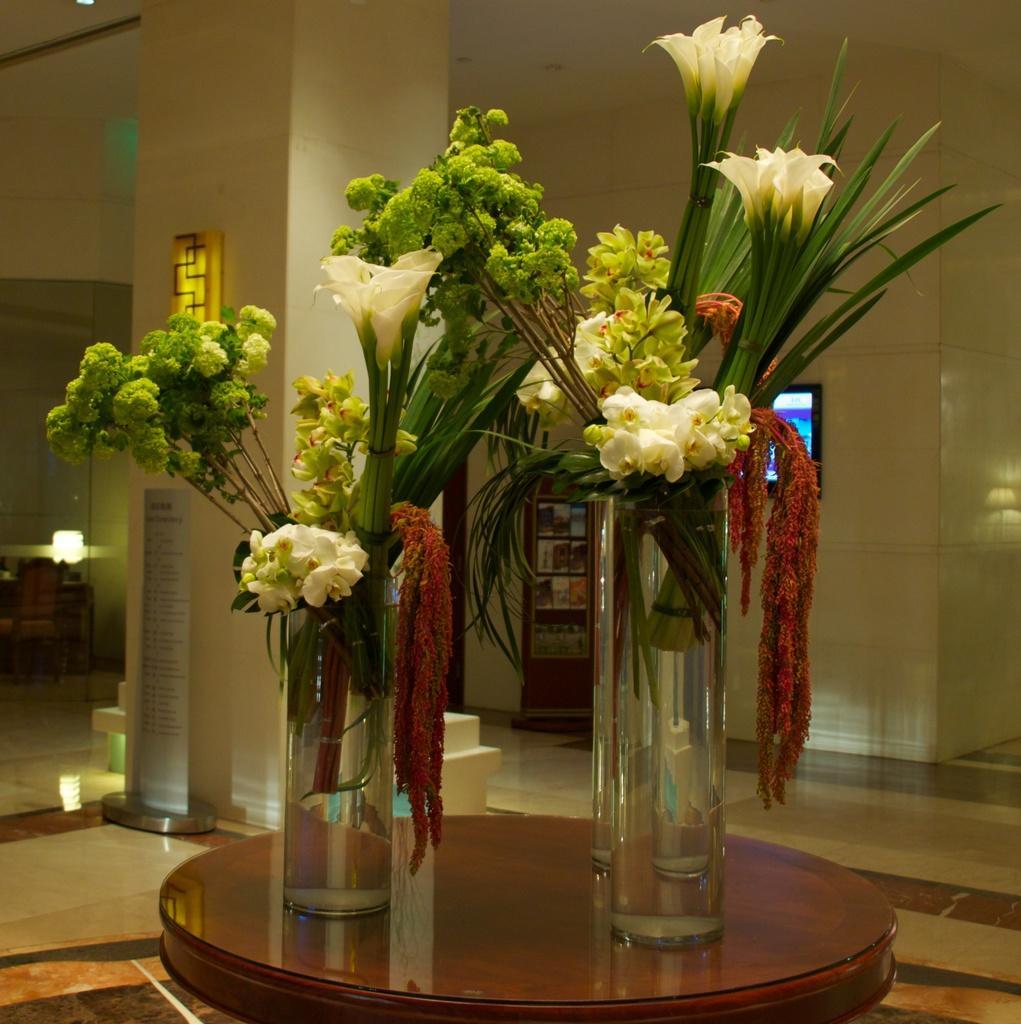In one or two sentences, can you explain what this image depicts? Here we can see flower plants in a glass placed on a table and behind them we can see a monitor and lights present 